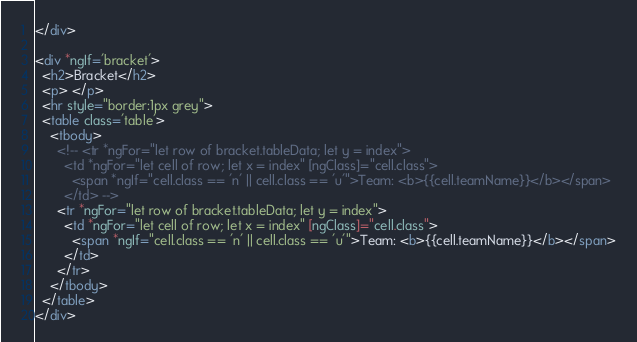<code> <loc_0><loc_0><loc_500><loc_500><_HTML_></div>

<div *ngIf='bracket'>
  <h2>Bracket</h2>
  <p> </p>
  <hr style="border:1px grey">
  <table class='table'>
    <tbody>
      <!-- <tr *ngFor="let row of bracket.tableData; let y = index">
        <td *ngFor="let cell of row; let x = index" [ngClass]="cell.class">
          <span *ngIf="cell.class == 'n' || cell.class == 'u'">Team: <b>{{cell.teamName}}</b></span>
        </td> -->
      <tr *ngFor="let row of bracket.tableData; let y = index">
        <td *ngFor="let cell of row; let x = index" [ngClass]="cell.class">
          <span *ngIf="cell.class == 'n' || cell.class == 'u'">Team: <b>{{cell.teamName}}</b></span>
        </td>
      </tr>
    </tbody>
  </table>
</div></code> 